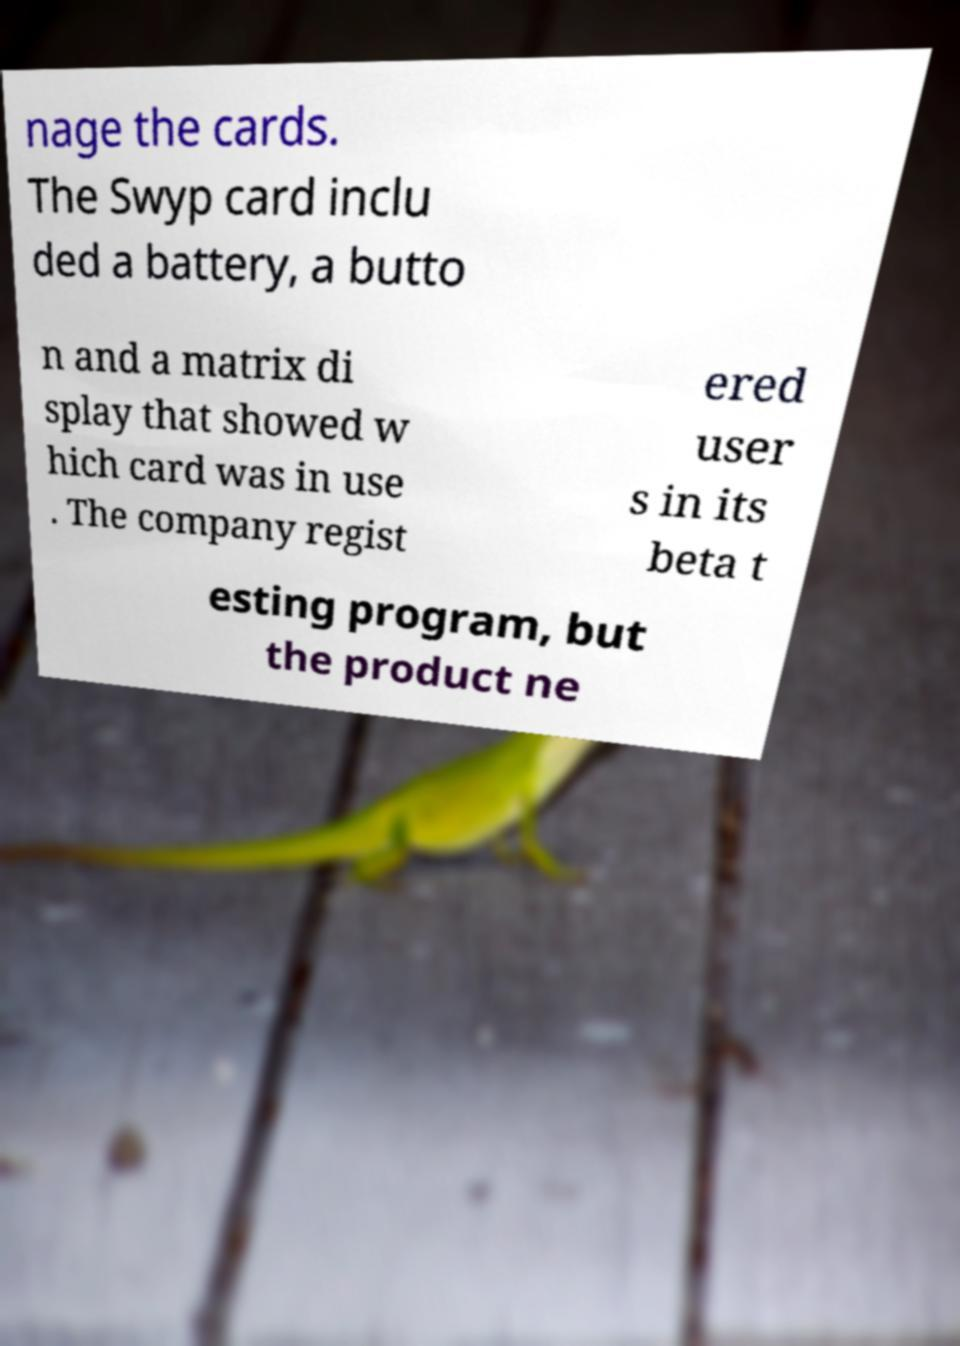For documentation purposes, I need the text within this image transcribed. Could you provide that? nage the cards. The Swyp card inclu ded a battery, a butto n and a matrix di splay that showed w hich card was in use . The company regist ered user s in its beta t esting program, but the product ne 